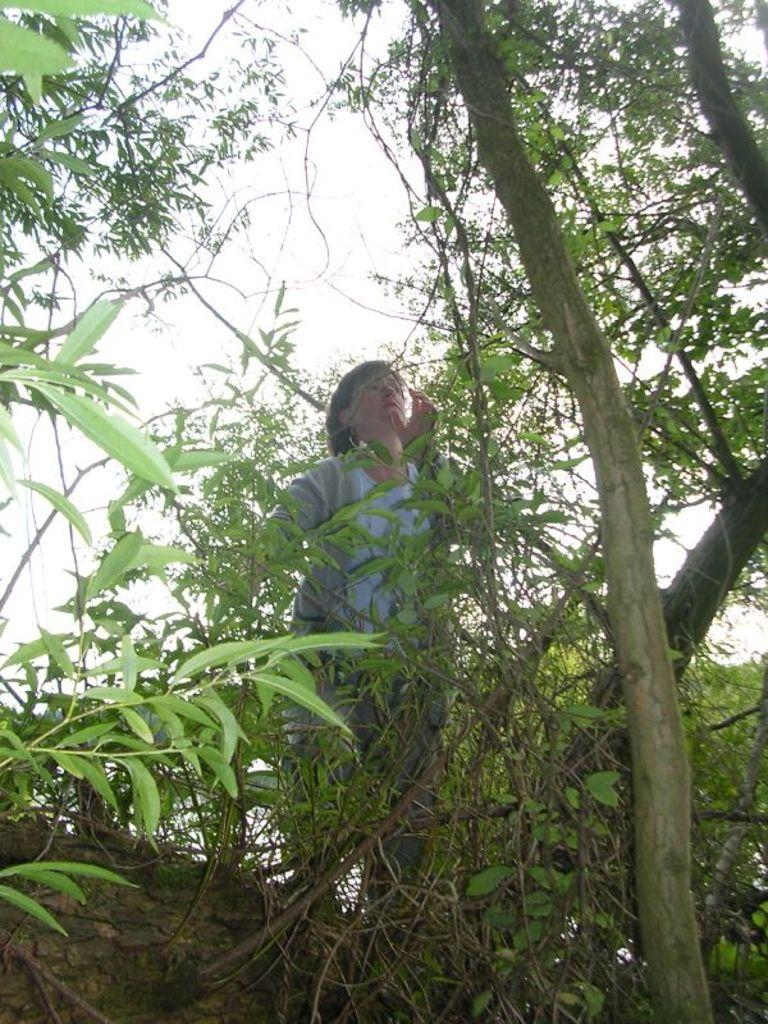Who is present in the image? There is a woman in the image. What is the woman standing between in the image? The woman is standing between plants and rocks. What can be seen in the background of the image? The sky is visible in the image. What type of sock is the woman wearing in the image? There is no information about the woman's socks in the image, so it cannot be determined. Has the woman received a letter in the image? There is no mention of a letter in the image, so it cannot be determined if the woman has received one. 